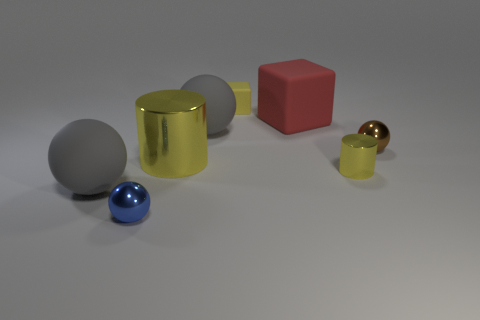Add 2 big matte spheres. How many objects exist? 10 Subtract all gray spheres. How many spheres are left? 2 Subtract all cylinders. How many objects are left? 6 Subtract all big blue metal blocks. Subtract all small yellow rubber blocks. How many objects are left? 7 Add 4 brown shiny spheres. How many brown shiny spheres are left? 5 Add 6 large yellow things. How many large yellow things exist? 7 Subtract 0 green cylinders. How many objects are left? 8 Subtract 1 cylinders. How many cylinders are left? 1 Subtract all cyan cylinders. Subtract all red blocks. How many cylinders are left? 2 Subtract all purple blocks. How many gray spheres are left? 2 